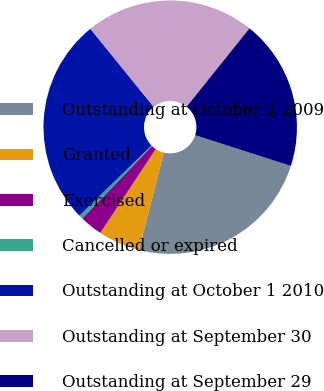<chart> <loc_0><loc_0><loc_500><loc_500><pie_chart><fcel>Outstanding at October 2 2009<fcel>Granted<fcel>Exercised<fcel>Cancelled or expired<fcel>Outstanding at October 1 2010<fcel>Outstanding at September 30<fcel>Outstanding at September 29<nl><fcel>24.02%<fcel>5.33%<fcel>2.91%<fcel>0.49%<fcel>26.44%<fcel>21.6%<fcel>19.18%<nl></chart> 